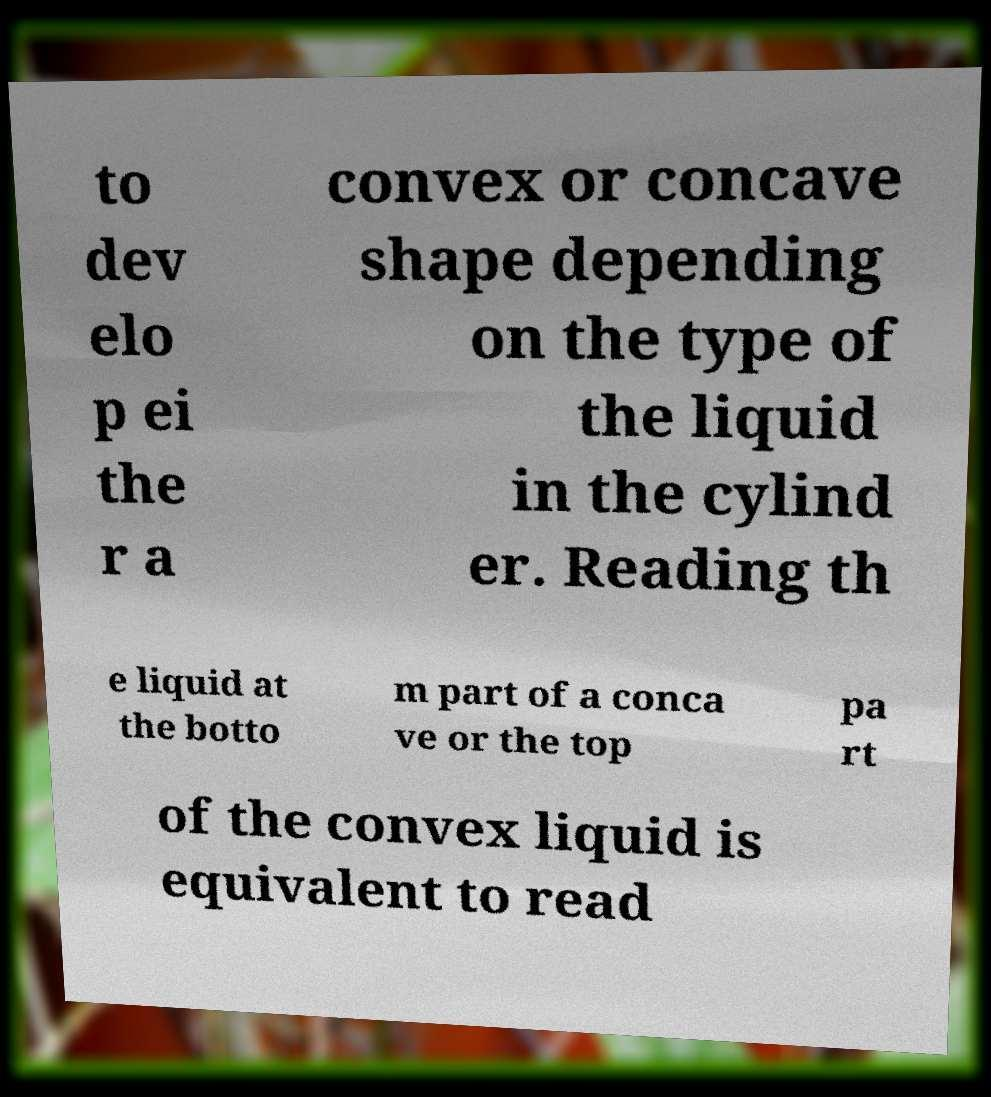Can you accurately transcribe the text from the provided image for me? to dev elo p ei the r a convex or concave shape depending on the type of the liquid in the cylind er. Reading th e liquid at the botto m part of a conca ve or the top pa rt of the convex liquid is equivalent to read 